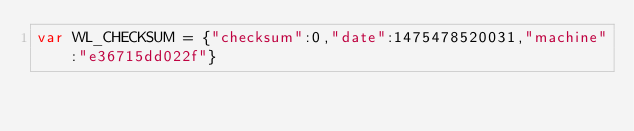Convert code to text. <code><loc_0><loc_0><loc_500><loc_500><_JavaScript_>var WL_CHECKSUM = {"checksum":0,"date":1475478520031,"machine":"e36715dd022f"}</code> 